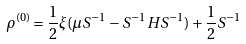<formula> <loc_0><loc_0><loc_500><loc_500>\rho ^ { ( 0 ) } = \frac { 1 } { 2 } \xi ( \mu S ^ { - 1 } - S ^ { - 1 } H S ^ { - 1 } ) + \frac { 1 } { 2 } S ^ { - 1 }</formula> 